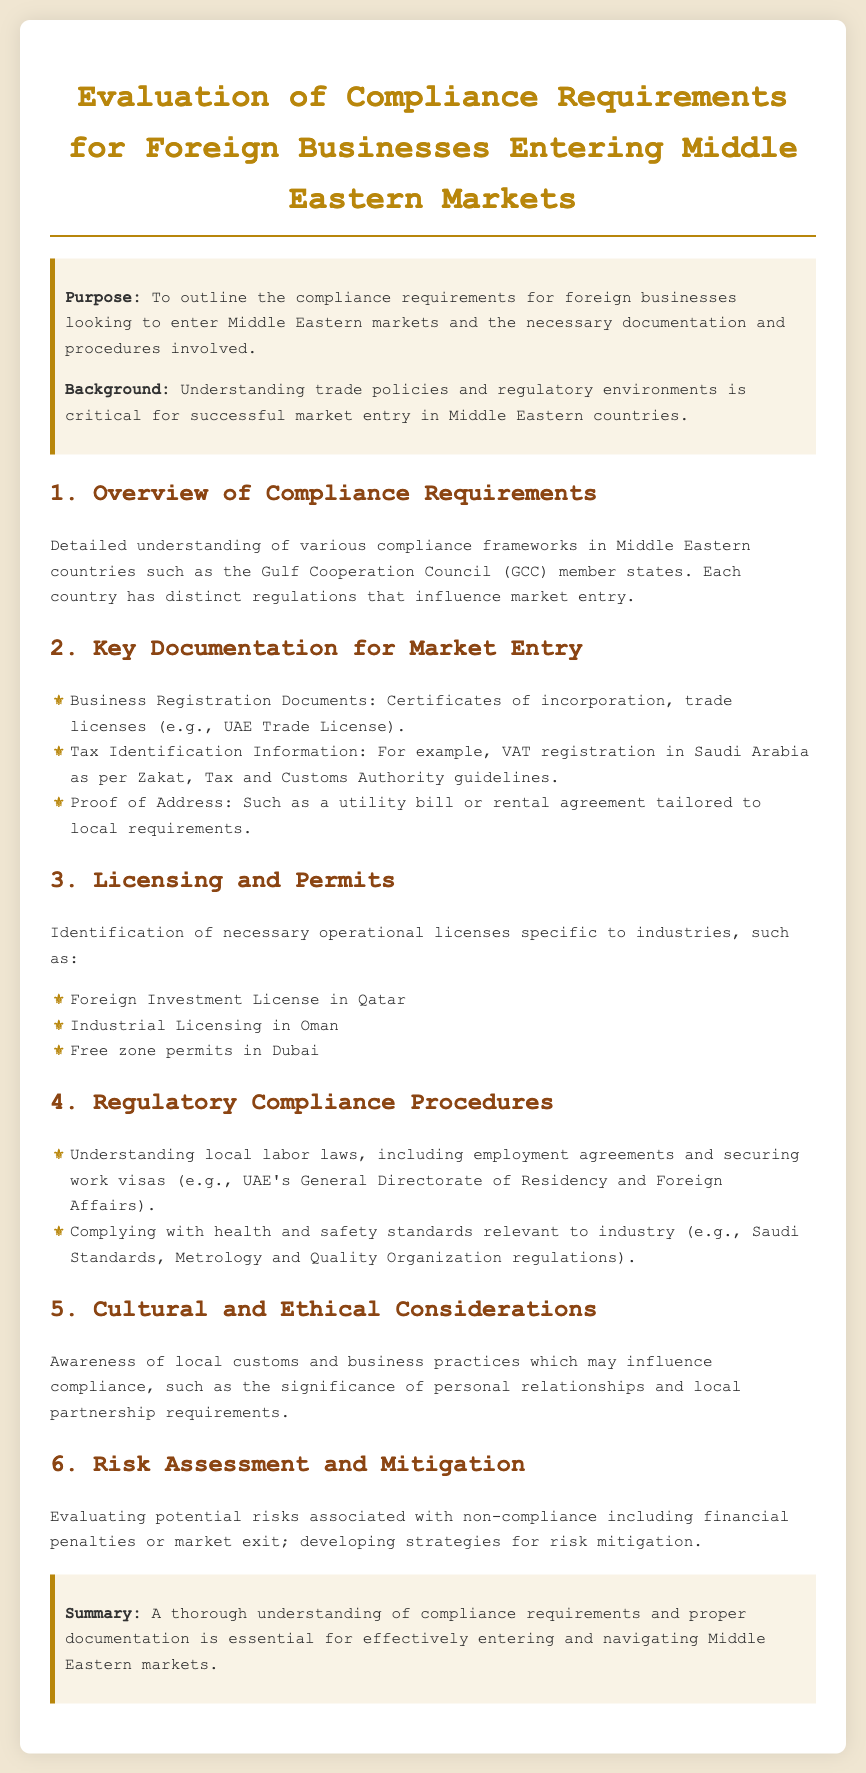what is the purpose of the document? The purpose is outlined in the introduction section, stating it is to outline the compliance requirements for foreign businesses.
Answer: To outline the compliance requirements for foreign businesses entering Middle Eastern markets which organization oversees VAT registration in Saudi Arabia? The organization mentioned in the document for VAT registration in Saudi Arabia is the Zakat, Tax and Customs Authority.
Answer: Zakat, Tax and Customs Authority name one licensing requirement specific to Qatar. The document lists the Foreign Investment License as a necessary licensing requirement specific to Qatar.
Answer: Foreign Investment License what is a key cultural consideration mentioned in the document? The document highlights the significance of personal relationships as a cultural consideration affecting compliance.
Answer: Significance of personal relationships what is one of the risk assessment areas discussed? One of the areas discussed includes potential financial penalties associated with non-compliance.
Answer: Financial penalties how does the document summarize the importance of compliance understanding? The conclusion emphasizes that a thorough understanding of compliance requirements is essential for effectively entering markets.
Answer: Essential for effectively entering Middle Eastern markets 